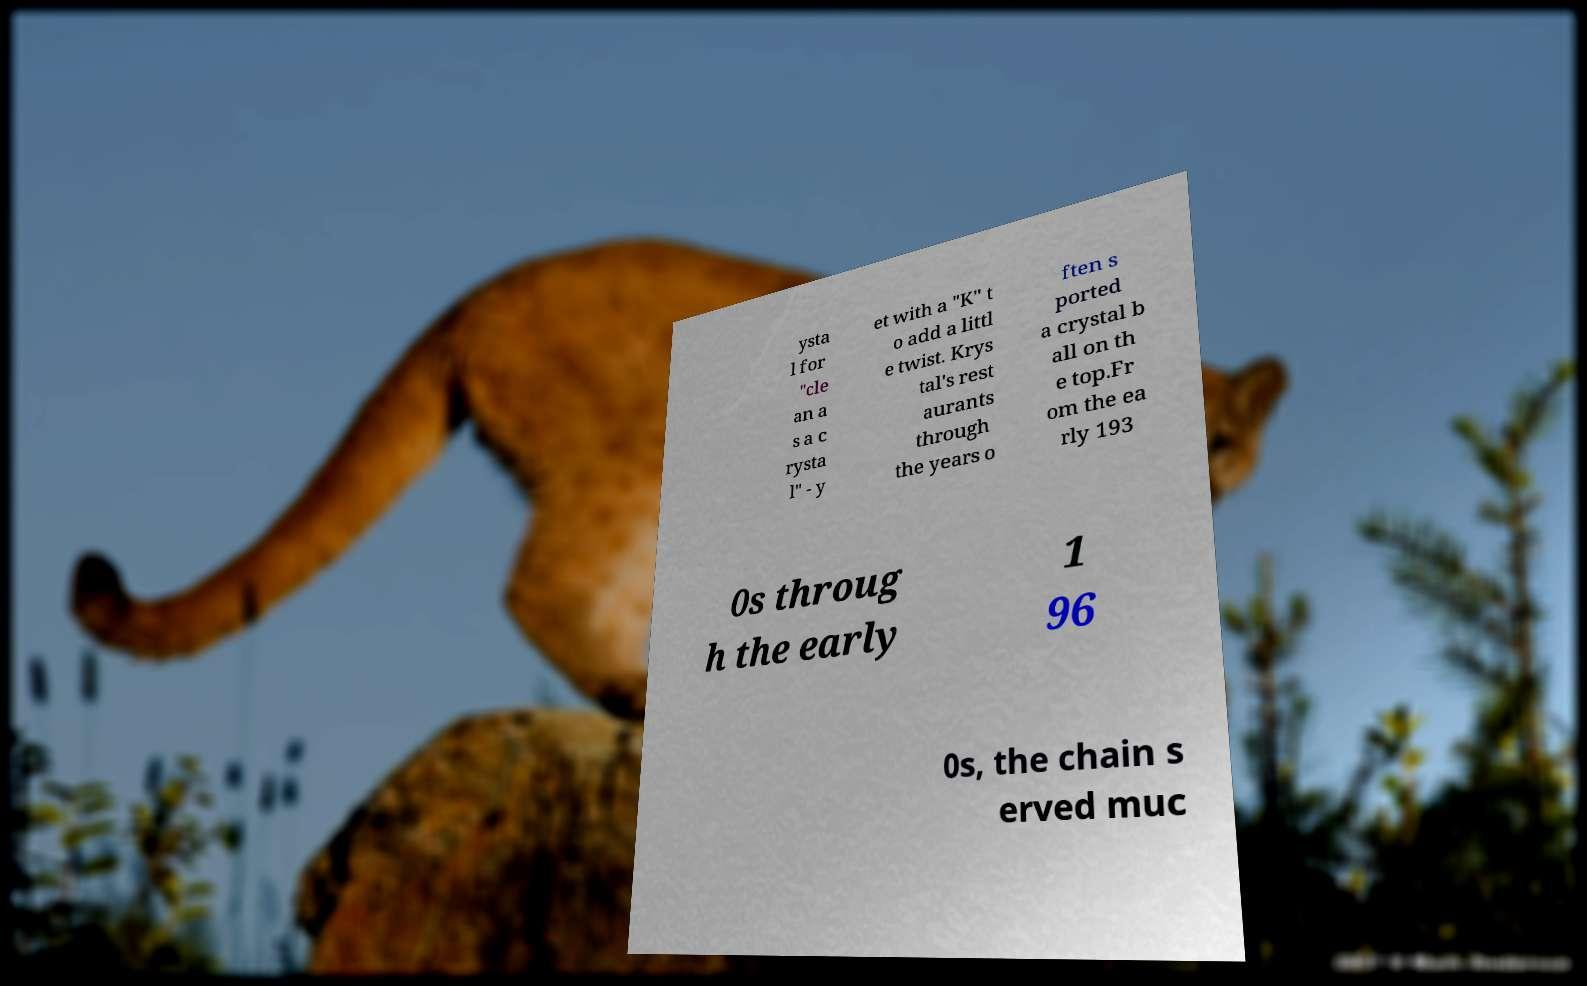Please read and relay the text visible in this image. What does it say? ysta l for "cle an a s a c rysta l" - y et with a "K" t o add a littl e twist. Krys tal's rest aurants through the years o ften s ported a crystal b all on th e top.Fr om the ea rly 193 0s throug h the early 1 96 0s, the chain s erved muc 